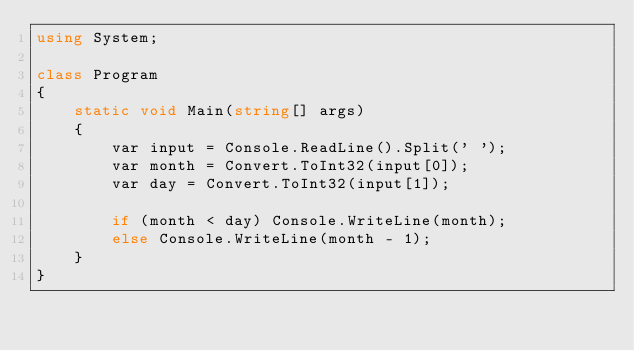<code> <loc_0><loc_0><loc_500><loc_500><_C#_>using System;

class Program
{
    static void Main(string[] args)
    {
        var input = Console.ReadLine().Split(' ');
        var month = Convert.ToInt32(input[0]);
        var day = Convert.ToInt32(input[1]);

        if (month < day) Console.WriteLine(month);
        else Console.WriteLine(month - 1);
    }
}
</code> 